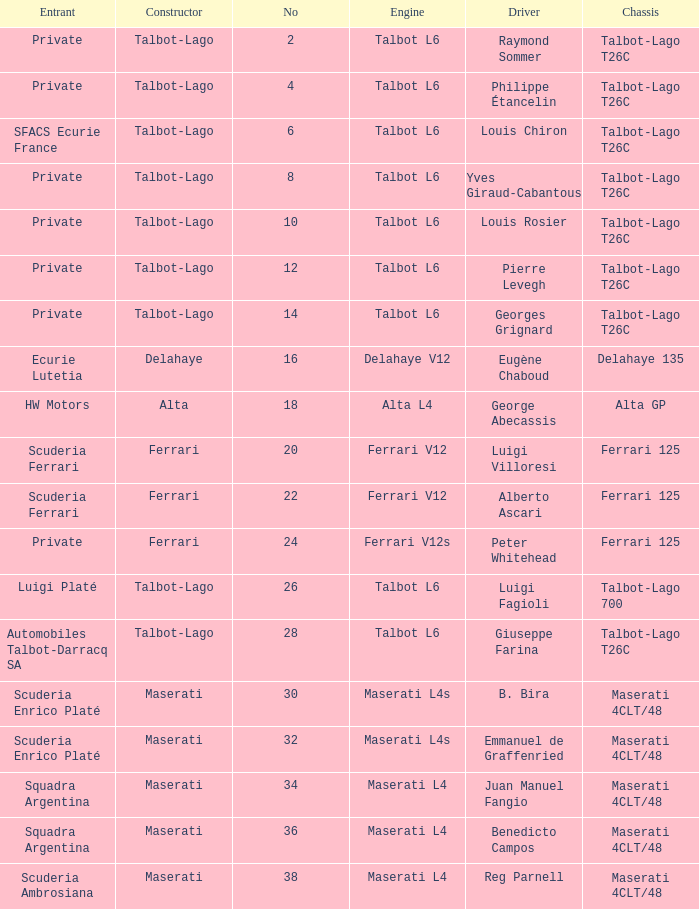Name the chassis for sfacs ecurie france Talbot-Lago T26C. 